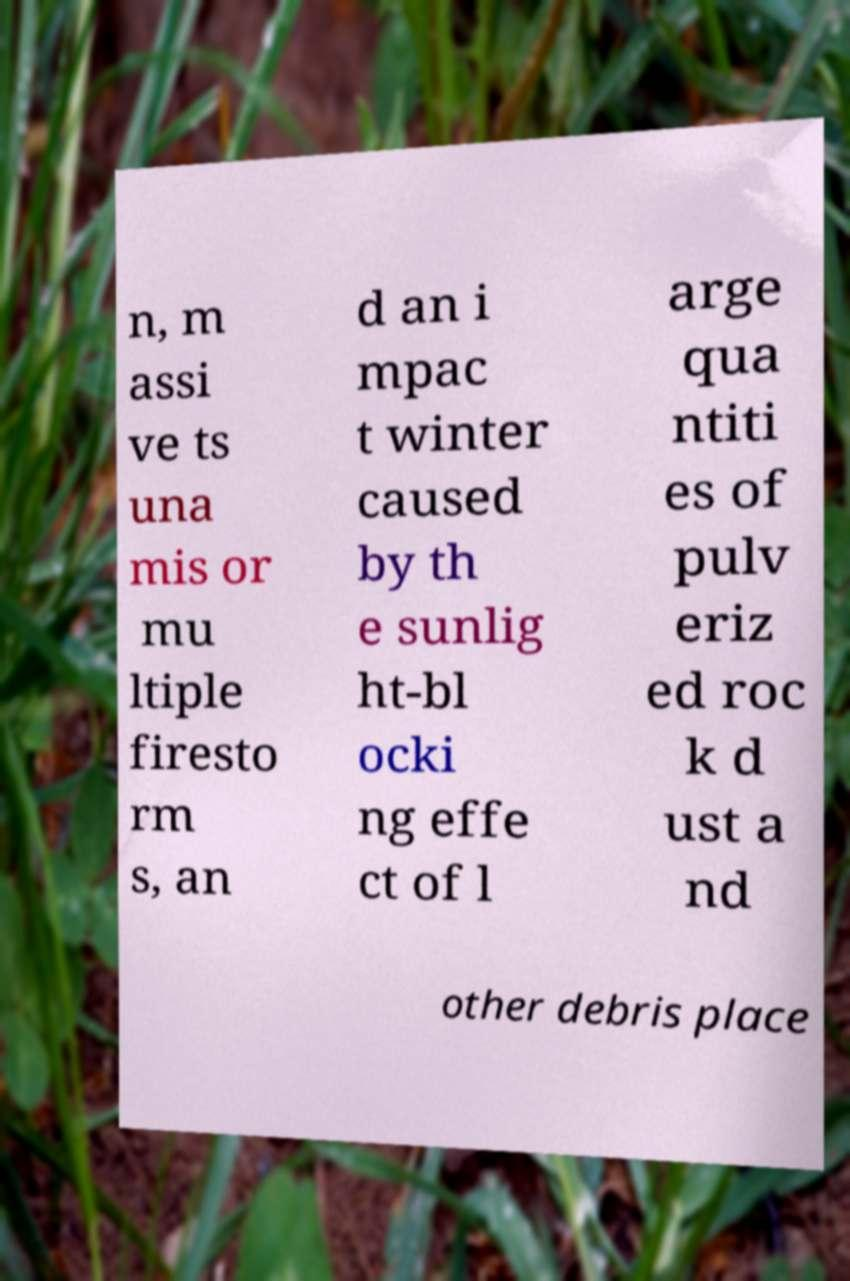Please read and relay the text visible in this image. What does it say? n, m assi ve ts una mis or mu ltiple firesto rm s, an d an i mpac t winter caused by th e sunlig ht-bl ocki ng effe ct of l arge qua ntiti es of pulv eriz ed roc k d ust a nd other debris place 